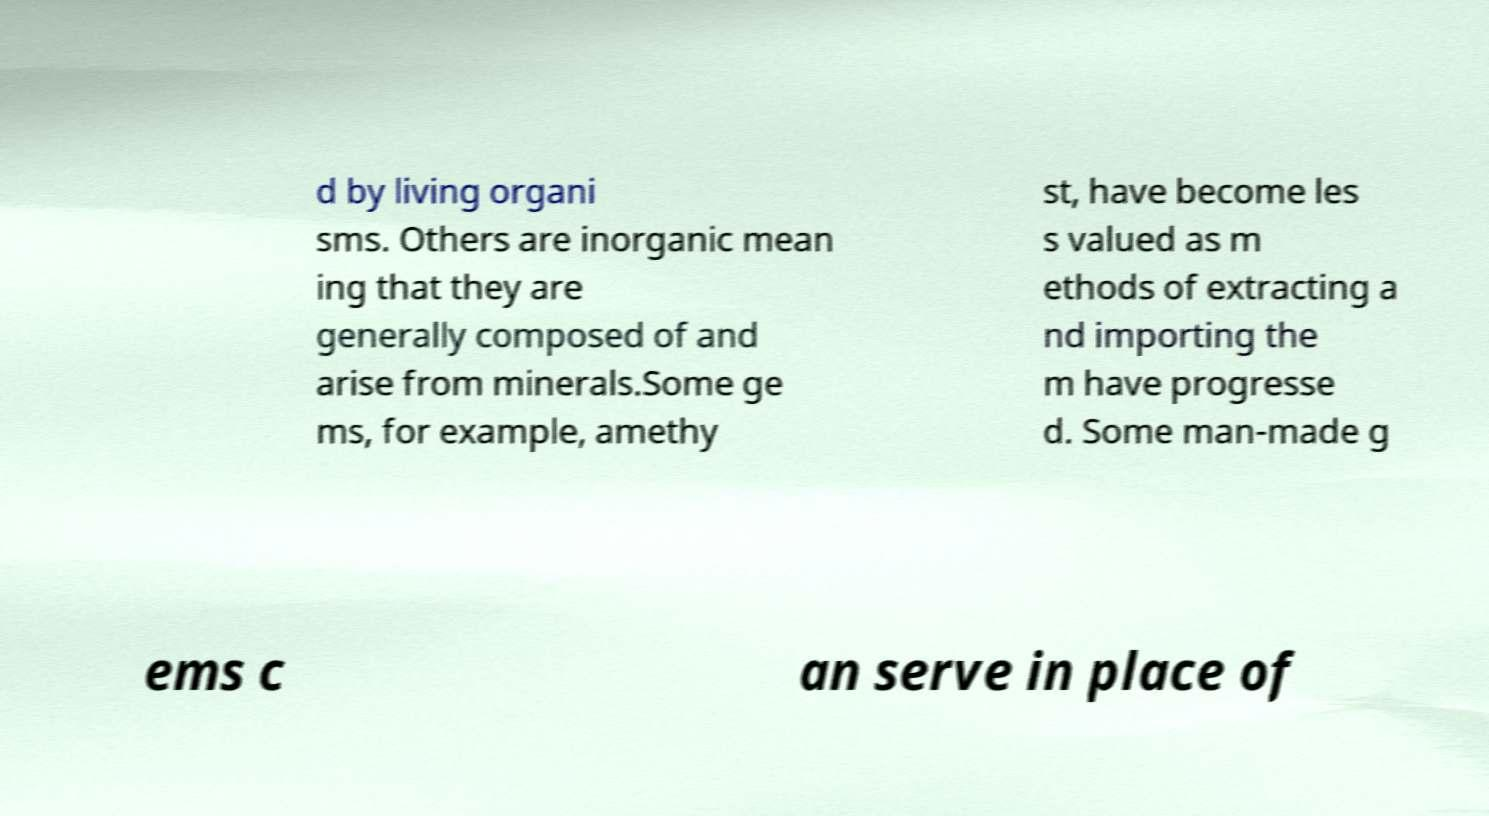Can you accurately transcribe the text from the provided image for me? d by living organi sms. Others are inorganic mean ing that they are generally composed of and arise from minerals.Some ge ms, for example, amethy st, have become les s valued as m ethods of extracting a nd importing the m have progresse d. Some man-made g ems c an serve in place of 